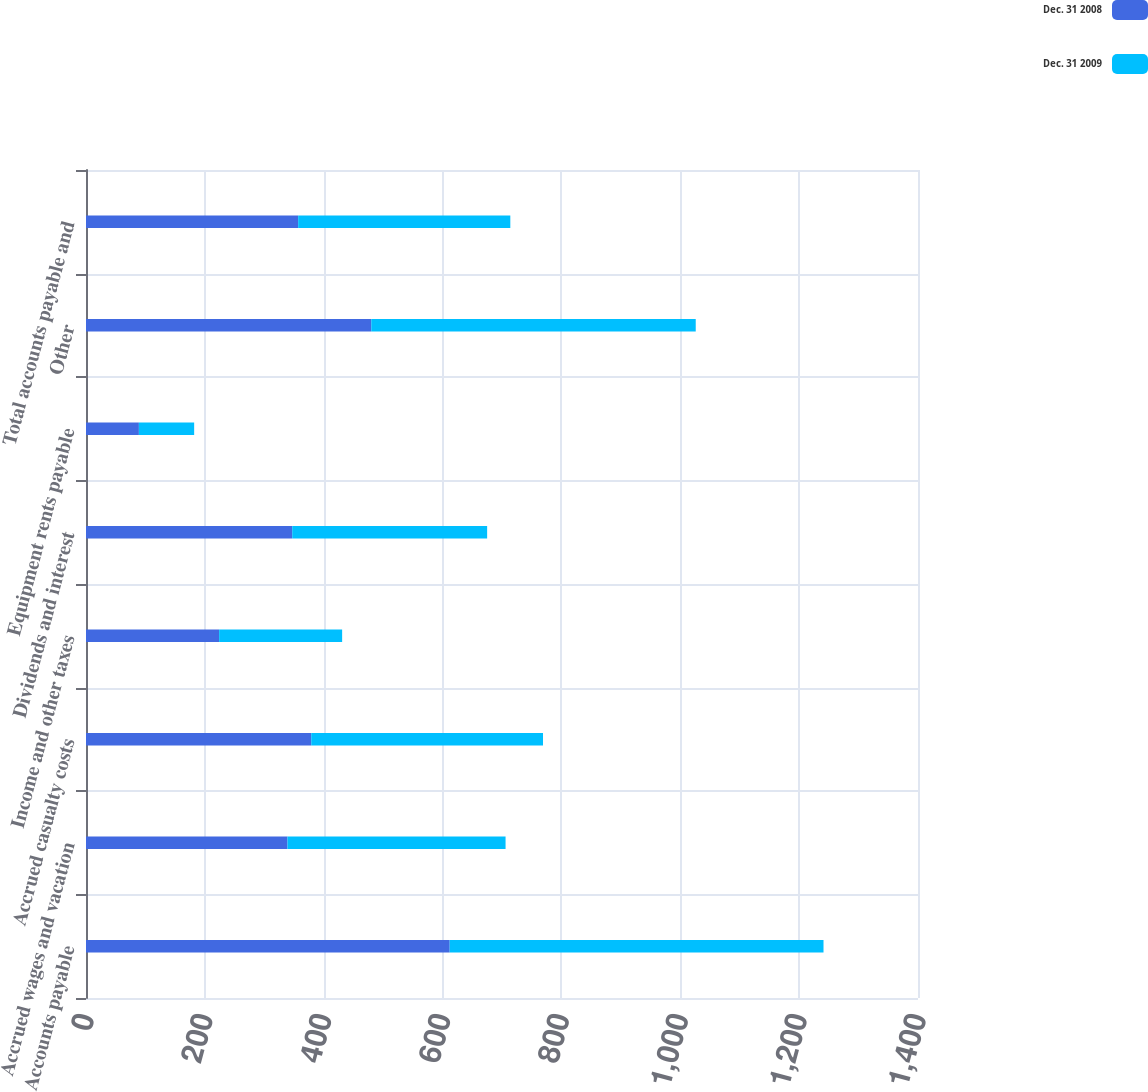Convert chart to OTSL. <chart><loc_0><loc_0><loc_500><loc_500><stacked_bar_chart><ecel><fcel>Accounts payable<fcel>Accrued wages and vacation<fcel>Accrued casualty costs<fcel>Income and other taxes<fcel>Dividends and interest<fcel>Equipment rents payable<fcel>Other<fcel>Total accounts payable and<nl><fcel>Dec. 31 2008<fcel>612<fcel>339<fcel>379<fcel>224<fcel>347<fcel>89<fcel>480<fcel>357<nl><fcel>Dec. 31 2009<fcel>629<fcel>367<fcel>390<fcel>207<fcel>328<fcel>93<fcel>546<fcel>357<nl></chart> 